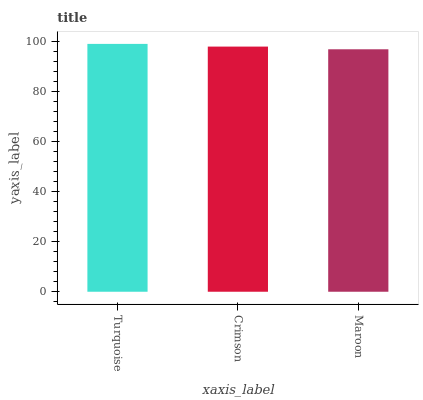Is Maroon the minimum?
Answer yes or no. Yes. Is Turquoise the maximum?
Answer yes or no. Yes. Is Crimson the minimum?
Answer yes or no. No. Is Crimson the maximum?
Answer yes or no. No. Is Turquoise greater than Crimson?
Answer yes or no. Yes. Is Crimson less than Turquoise?
Answer yes or no. Yes. Is Crimson greater than Turquoise?
Answer yes or no. No. Is Turquoise less than Crimson?
Answer yes or no. No. Is Crimson the high median?
Answer yes or no. Yes. Is Crimson the low median?
Answer yes or no. Yes. Is Turquoise the high median?
Answer yes or no. No. Is Turquoise the low median?
Answer yes or no. No. 